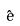<formula> <loc_0><loc_0><loc_500><loc_500>\hat { e }</formula> 